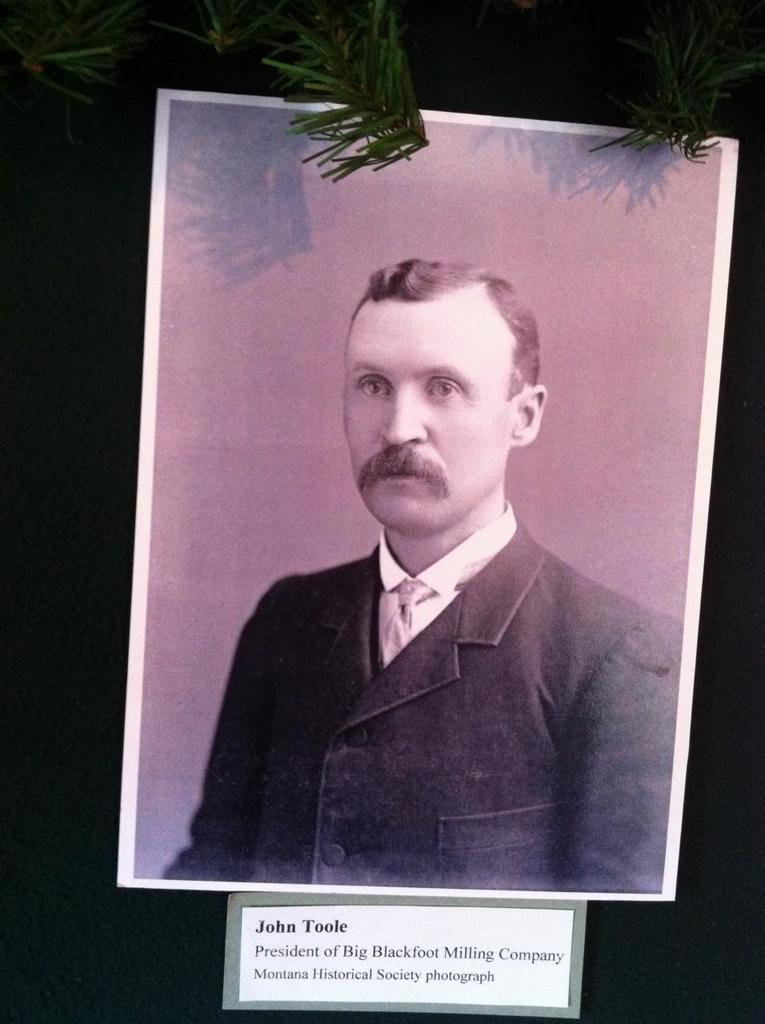What is the main subject of the poster in the image? There is a poster of a person in the image. Where is the poster located in relation to the viewer? The poster is in front. What is written or displayed on the board at the bottom of the image? There is text on a board at the bottom of the image. What can be seen in the background of the image? There is a tree in the background of the image. How many deer are visible in the image? There are no deer present in the image. What time of day is depicted in the image? The time of day is not mentioned or depicted in the image. 